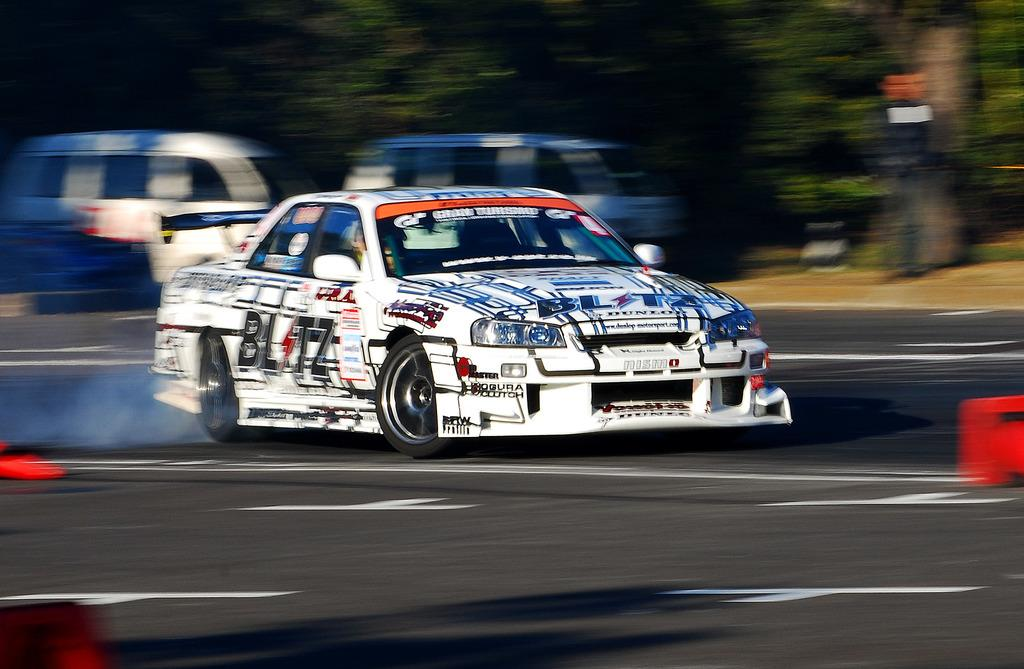What types of vehicles can be seen on the road in the image? There are motor vehicles on the road in the image. Can you describe the person in the image? There is a person standing on the ground in the image. What type of natural elements are present in the image? There are trees in the image. What type of eggnog is being served at the meeting in the image? There is no meeting or eggnog present in the image. Can you describe the feather on the person's hat in the image? There is no feather or hat present on the person in the image. 